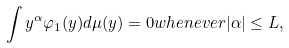Convert formula to latex. <formula><loc_0><loc_0><loc_500><loc_500>\int y ^ { \alpha } \varphi _ { 1 } ( y ) d \mu ( y ) = 0 w h e n e v e r | \alpha | \leq L ,</formula> 